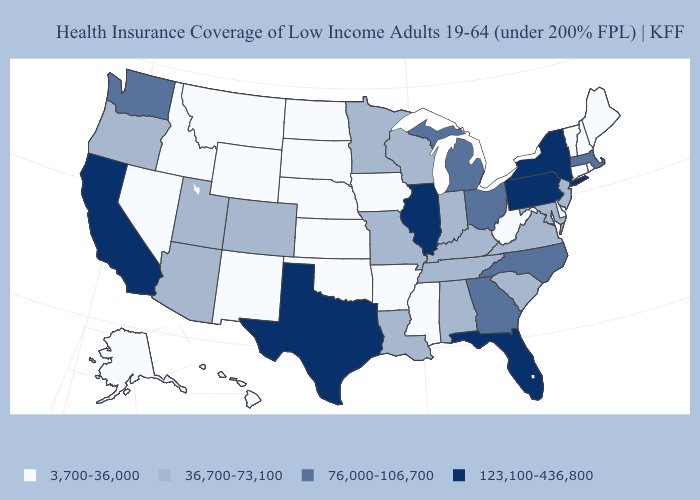What is the value of South Dakota?
Give a very brief answer. 3,700-36,000. What is the lowest value in the USA?
Give a very brief answer. 3,700-36,000. Does New Hampshire have the highest value in the Northeast?
Write a very short answer. No. Name the states that have a value in the range 36,700-73,100?
Keep it brief. Alabama, Arizona, Colorado, Indiana, Kentucky, Louisiana, Maryland, Minnesota, Missouri, New Jersey, Oregon, South Carolina, Tennessee, Utah, Virginia, Wisconsin. Among the states that border Florida , does Georgia have the highest value?
Be succinct. Yes. What is the value of Michigan?
Answer briefly. 76,000-106,700. Name the states that have a value in the range 76,000-106,700?
Short answer required. Georgia, Massachusetts, Michigan, North Carolina, Ohio, Washington. Does the map have missing data?
Concise answer only. No. What is the value of New Jersey?
Concise answer only. 36,700-73,100. Among the states that border Iowa , does South Dakota have the lowest value?
Keep it brief. Yes. Name the states that have a value in the range 3,700-36,000?
Write a very short answer. Alaska, Arkansas, Connecticut, Delaware, Hawaii, Idaho, Iowa, Kansas, Maine, Mississippi, Montana, Nebraska, Nevada, New Hampshire, New Mexico, North Dakota, Oklahoma, Rhode Island, South Dakota, Vermont, West Virginia, Wyoming. Among the states that border Washington , does Oregon have the lowest value?
Answer briefly. No. Does the map have missing data?
Be succinct. No. Name the states that have a value in the range 123,100-436,800?
Quick response, please. California, Florida, Illinois, New York, Pennsylvania, Texas. Which states have the lowest value in the USA?
Give a very brief answer. Alaska, Arkansas, Connecticut, Delaware, Hawaii, Idaho, Iowa, Kansas, Maine, Mississippi, Montana, Nebraska, Nevada, New Hampshire, New Mexico, North Dakota, Oklahoma, Rhode Island, South Dakota, Vermont, West Virginia, Wyoming. 